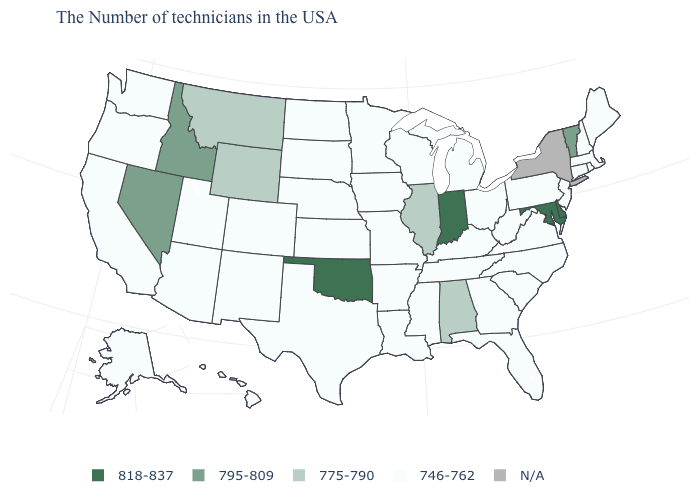Which states have the lowest value in the USA?
Give a very brief answer. Maine, Massachusetts, Rhode Island, New Hampshire, Connecticut, New Jersey, Pennsylvania, Virginia, North Carolina, South Carolina, West Virginia, Ohio, Florida, Georgia, Michigan, Kentucky, Tennessee, Wisconsin, Mississippi, Louisiana, Missouri, Arkansas, Minnesota, Iowa, Kansas, Nebraska, Texas, South Dakota, North Dakota, Colorado, New Mexico, Utah, Arizona, California, Washington, Oregon, Alaska, Hawaii. What is the value of Massachusetts?
Keep it brief. 746-762. What is the value of Rhode Island?
Be succinct. 746-762. Does Vermont have the highest value in the Northeast?
Short answer required. Yes. Does Maryland have the highest value in the USA?
Short answer required. Yes. Name the states that have a value in the range 818-837?
Quick response, please. Delaware, Maryland, Indiana, Oklahoma. Among the states that border South Dakota , does Minnesota have the highest value?
Give a very brief answer. No. What is the value of Ohio?
Be succinct. 746-762. What is the highest value in the USA?
Be succinct. 818-837. Does Maryland have the highest value in the South?
Keep it brief. Yes. Among the states that border Oregon , does Idaho have the lowest value?
Give a very brief answer. No. Which states have the lowest value in the South?
Write a very short answer. Virginia, North Carolina, South Carolina, West Virginia, Florida, Georgia, Kentucky, Tennessee, Mississippi, Louisiana, Arkansas, Texas. What is the highest value in the South ?
Concise answer only. 818-837. Name the states that have a value in the range 795-809?
Write a very short answer. Vermont, Idaho, Nevada. 